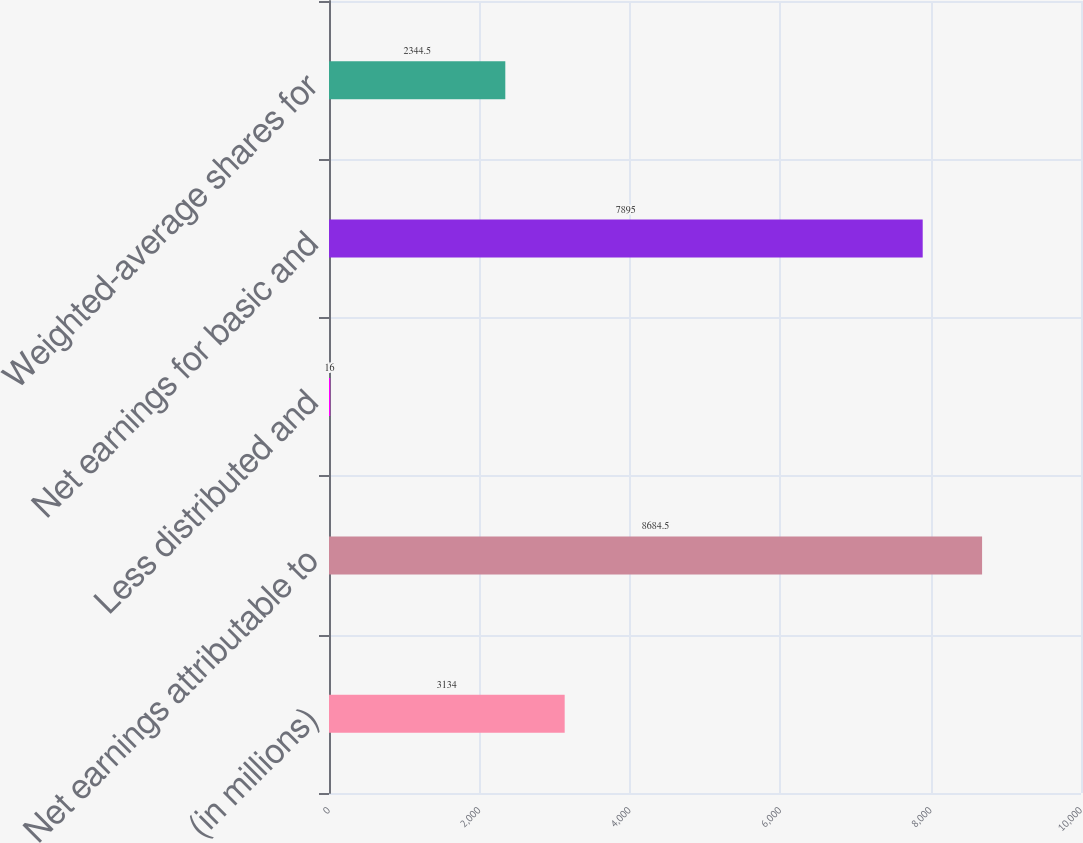<chart> <loc_0><loc_0><loc_500><loc_500><bar_chart><fcel>(in millions)<fcel>Net earnings attributable to<fcel>Less distributed and<fcel>Net earnings for basic and<fcel>Weighted-average shares for<nl><fcel>3134<fcel>8684.5<fcel>16<fcel>7895<fcel>2344.5<nl></chart> 